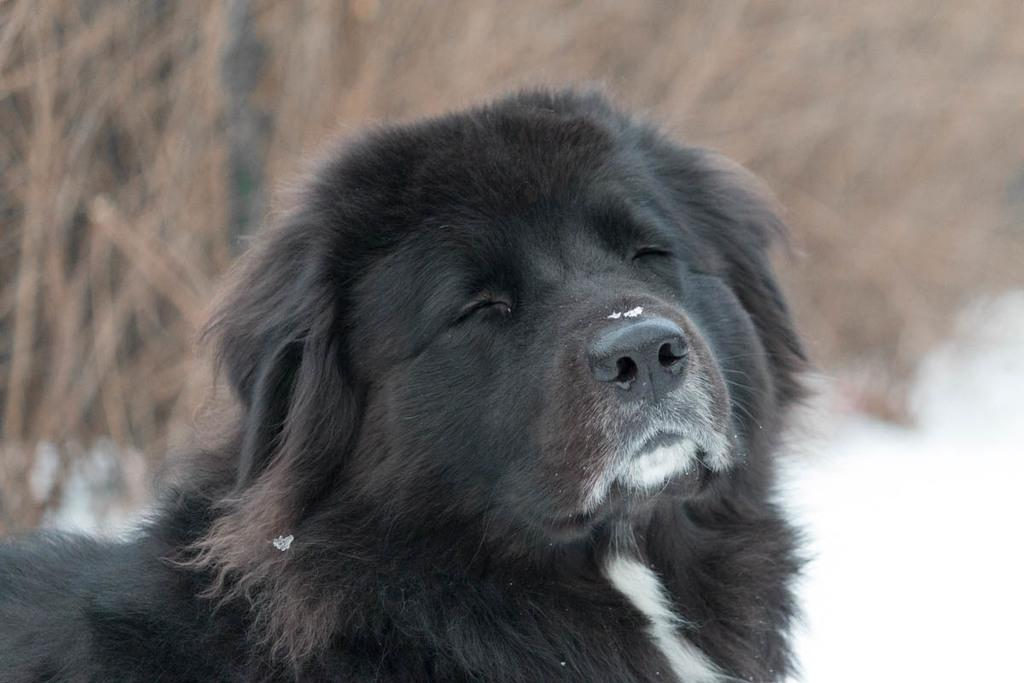What type of animal is in the image? There is a black color dog in the image. Can you describe the background of the image? The background of the image is blurred. How many trees can be seen in the image? There are no trees visible in the image; it only features a black color dog. What type of expression does the dog have on its face? The image does not show the dog's facial expression, so it cannot be determined if the dog is smiling or not. 